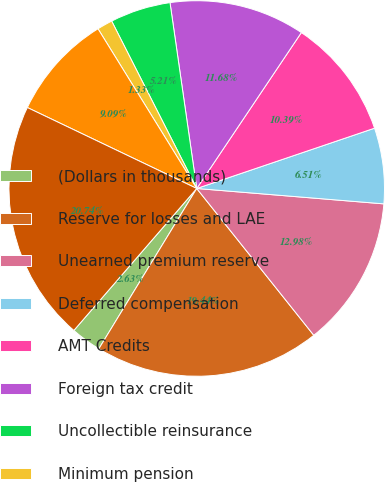Convert chart to OTSL. <chart><loc_0><loc_0><loc_500><loc_500><pie_chart><fcel>(Dollars in thousands)<fcel>Reserve for losses and LAE<fcel>Unearned premium reserve<fcel>Deferred compensation<fcel>AMT Credits<fcel>Foreign tax credit<fcel>Uncollectible reinsurance<fcel>Minimum pension<fcel>Other assets<fcel>Total deferred tax assets<nl><fcel>2.63%<fcel>19.44%<fcel>12.98%<fcel>6.51%<fcel>10.39%<fcel>11.68%<fcel>5.21%<fcel>1.33%<fcel>9.09%<fcel>20.74%<nl></chart> 